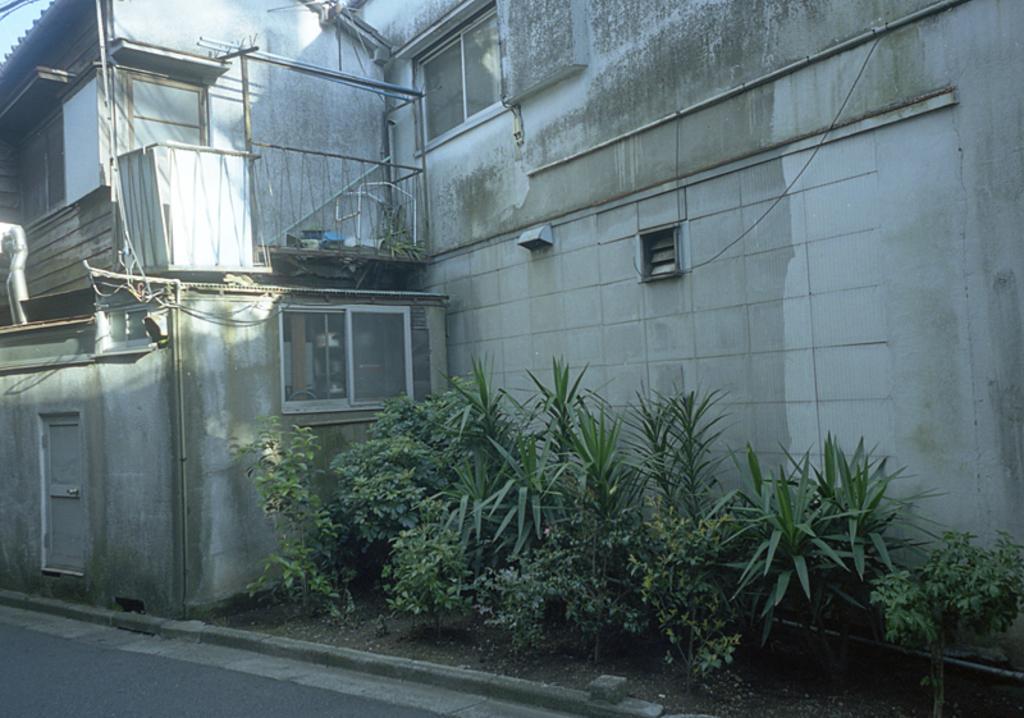Could you give a brief overview of what you see in this image? In the center of the image there is a building. At the bottom there are plants and a road. 